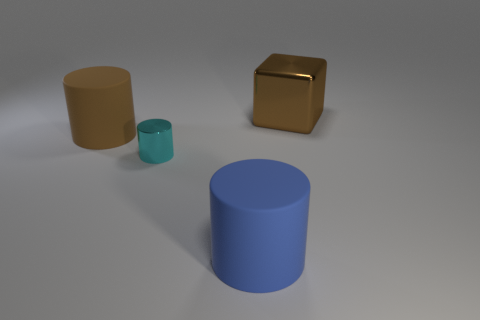Subtract all big brown rubber cylinders. How many cylinders are left? 2 Subtract 1 blocks. How many blocks are left? 0 Subtract all red cylinders. Subtract all green cubes. How many cylinders are left? 3 Add 2 blue matte things. How many blue matte things are left? 3 Add 2 big brown shiny cubes. How many big brown shiny cubes exist? 3 Add 3 blue cylinders. How many objects exist? 7 Subtract all blue cylinders. How many cylinders are left? 2 Subtract 0 green cylinders. How many objects are left? 4 Subtract all blocks. How many objects are left? 3 Subtract all gray balls. How many brown cylinders are left? 1 